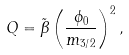<formula> <loc_0><loc_0><loc_500><loc_500>Q = \tilde { \beta } \left ( \frac { \phi _ { 0 } } { m _ { 3 / 2 } } \right ) ^ { 2 } ,</formula> 